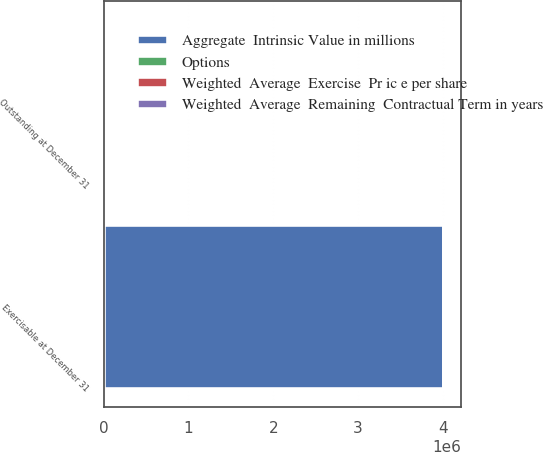Convert chart to OTSL. <chart><loc_0><loc_0><loc_500><loc_500><stacked_bar_chart><ecel><fcel>Outstanding at December 31<fcel>Exercisable at December 31<nl><fcel>Aggregate  Intrinsic Value in millions<fcel>52.87<fcel>4.01717e+06<nl><fcel>Weighted  Average  Remaining  Contractual Term in years<fcel>52.87<fcel>46.14<nl><fcel>Options<fcel>6.4<fcel>5.3<nl><fcel>Weighted  Average  Exercise  Pr ic e per share<fcel>209<fcel>161<nl></chart> 